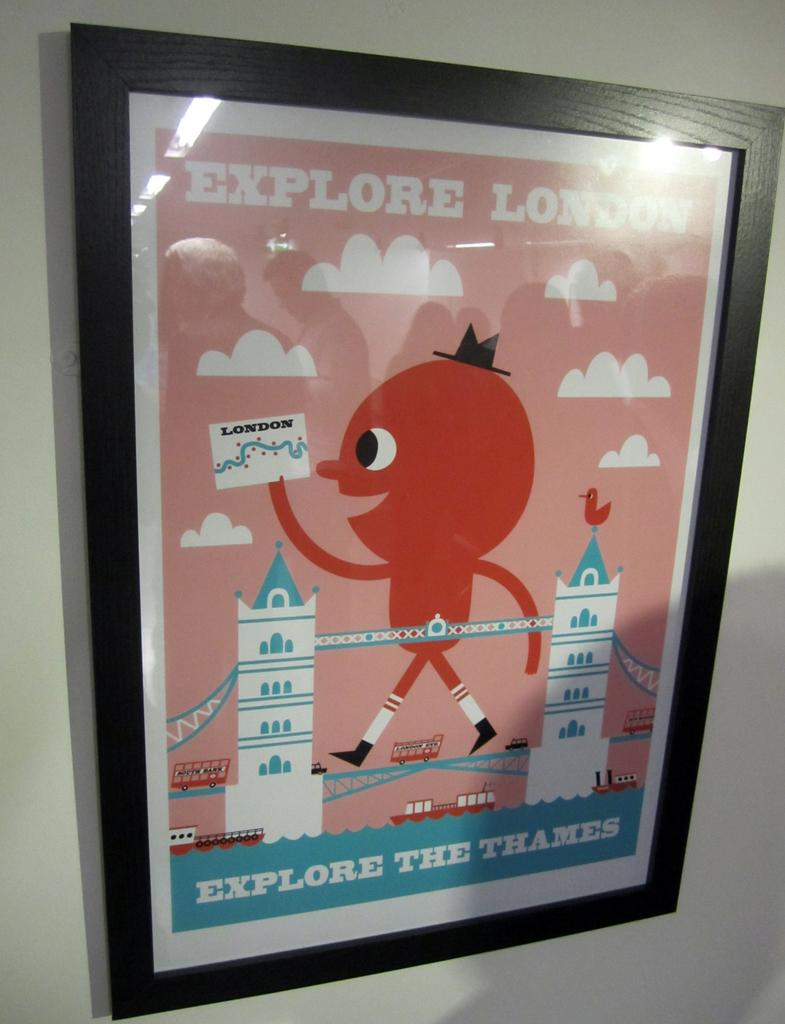<image>
Render a clear and concise summary of the photo. A travel poster for London and the Thames river. 